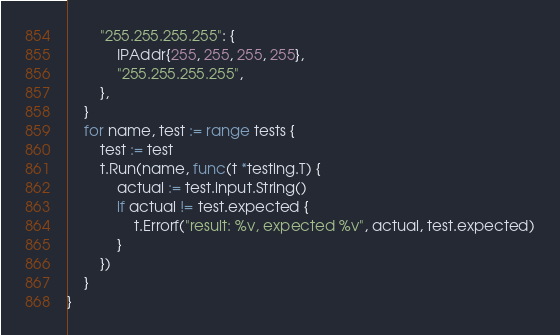<code> <loc_0><loc_0><loc_500><loc_500><_Go_>		"255.255.255.255": {
			IPAddr{255, 255, 255, 255},
			"255.255.255.255",
		},
	}
	for name, test := range tests {
		test := test
		t.Run(name, func(t *testing.T) {
			actual := test.input.String()
			if actual != test.expected {
				t.Errorf("result: %v, expected %v", actual, test.expected)
			}
		})
	}
}
</code> 